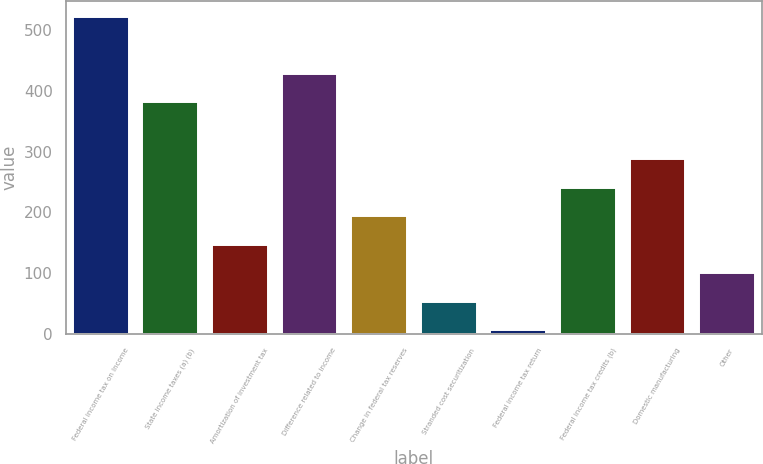<chart> <loc_0><loc_0><loc_500><loc_500><bar_chart><fcel>Federal income tax on Income<fcel>State income taxes (a) (b)<fcel>Amortization of investment tax<fcel>Difference related to income<fcel>Change in federal tax reserves<fcel>Stranded cost securitization<fcel>Federal income tax return<fcel>Federal income tax credits (b)<fcel>Domestic manufacturing<fcel>Other<nl><fcel>521.9<fcel>381.2<fcel>146.7<fcel>428.1<fcel>193.6<fcel>52.9<fcel>6<fcel>240.5<fcel>287.4<fcel>99.8<nl></chart> 